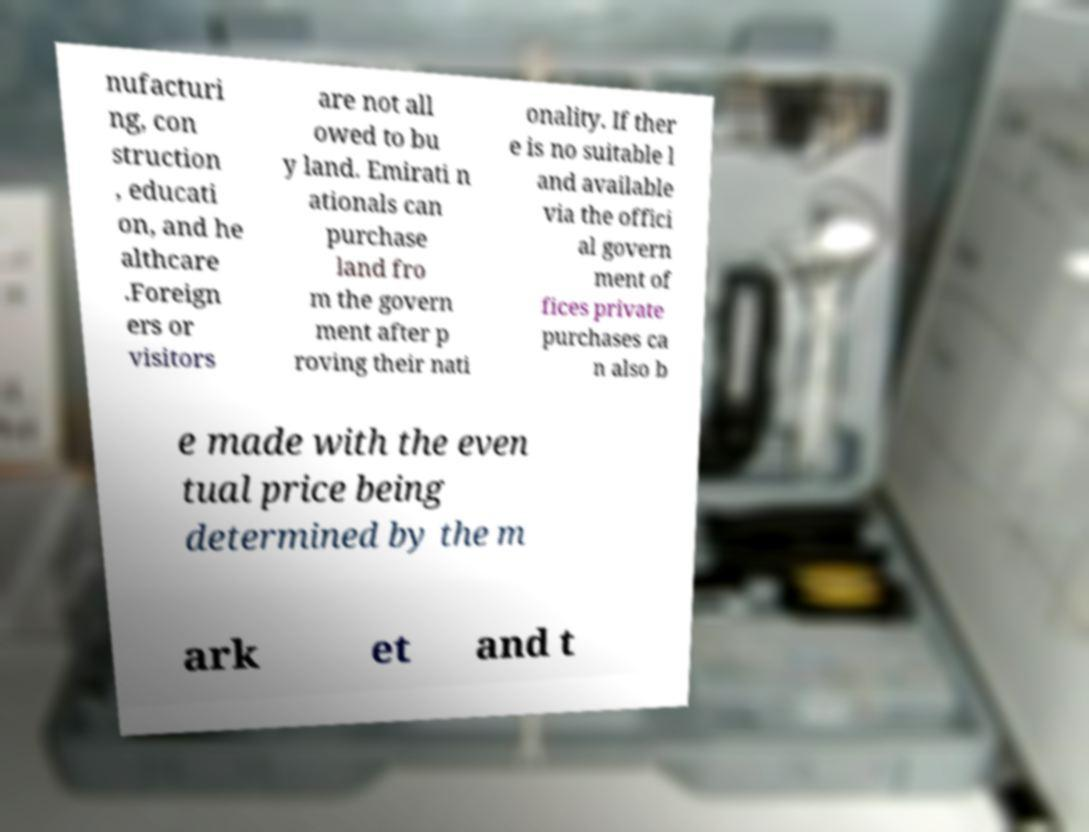I need the written content from this picture converted into text. Can you do that? nufacturi ng, con struction , educati on, and he althcare .Foreign ers or visitors are not all owed to bu y land. Emirati n ationals can purchase land fro m the govern ment after p roving their nati onality. If ther e is no suitable l and available via the offici al govern ment of fices private purchases ca n also b e made with the even tual price being determined by the m ark et and t 